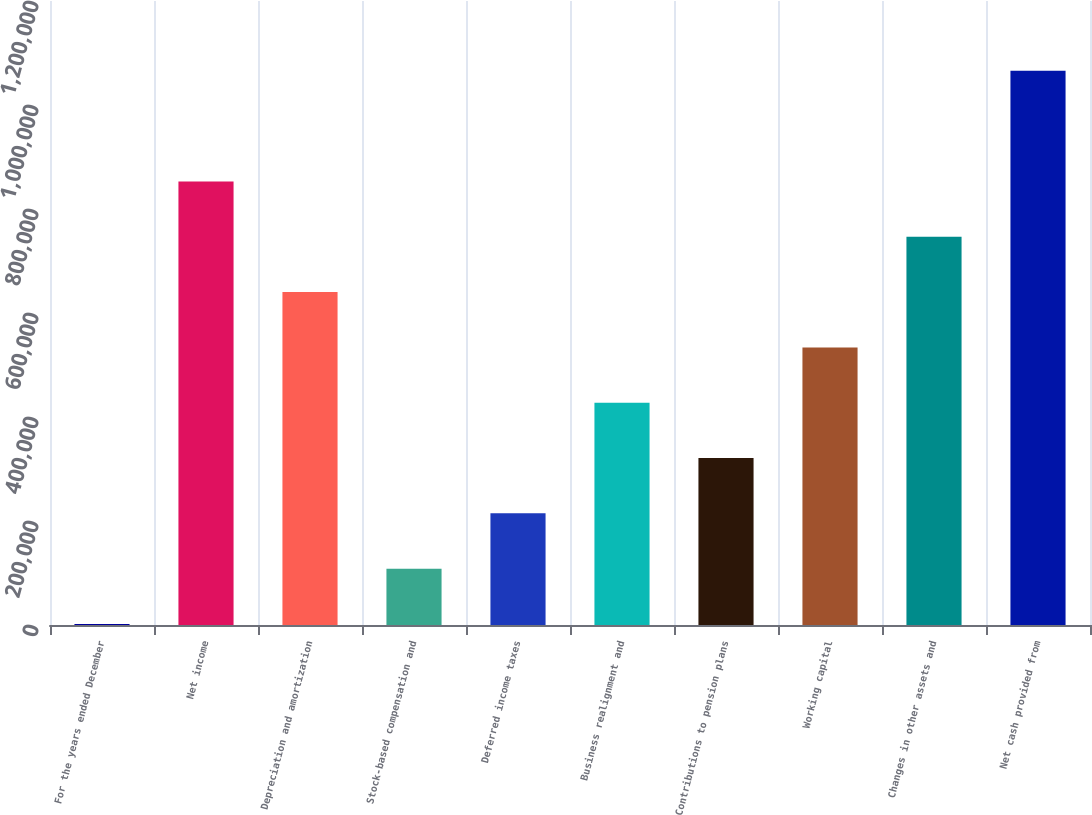Convert chart to OTSL. <chart><loc_0><loc_0><loc_500><loc_500><bar_chart><fcel>For the years ended December<fcel>Net income<fcel>Depreciation and amortization<fcel>Stock-based compensation and<fcel>Deferred income taxes<fcel>Business realignment and<fcel>Contributions to pension plans<fcel>Working capital<fcel>Changes in other assets and<fcel>Net cash provided from<nl><fcel>2009<fcel>853001<fcel>640253<fcel>108383<fcel>214757<fcel>427505<fcel>321131<fcel>533879<fcel>746627<fcel>1.06575e+06<nl></chart> 